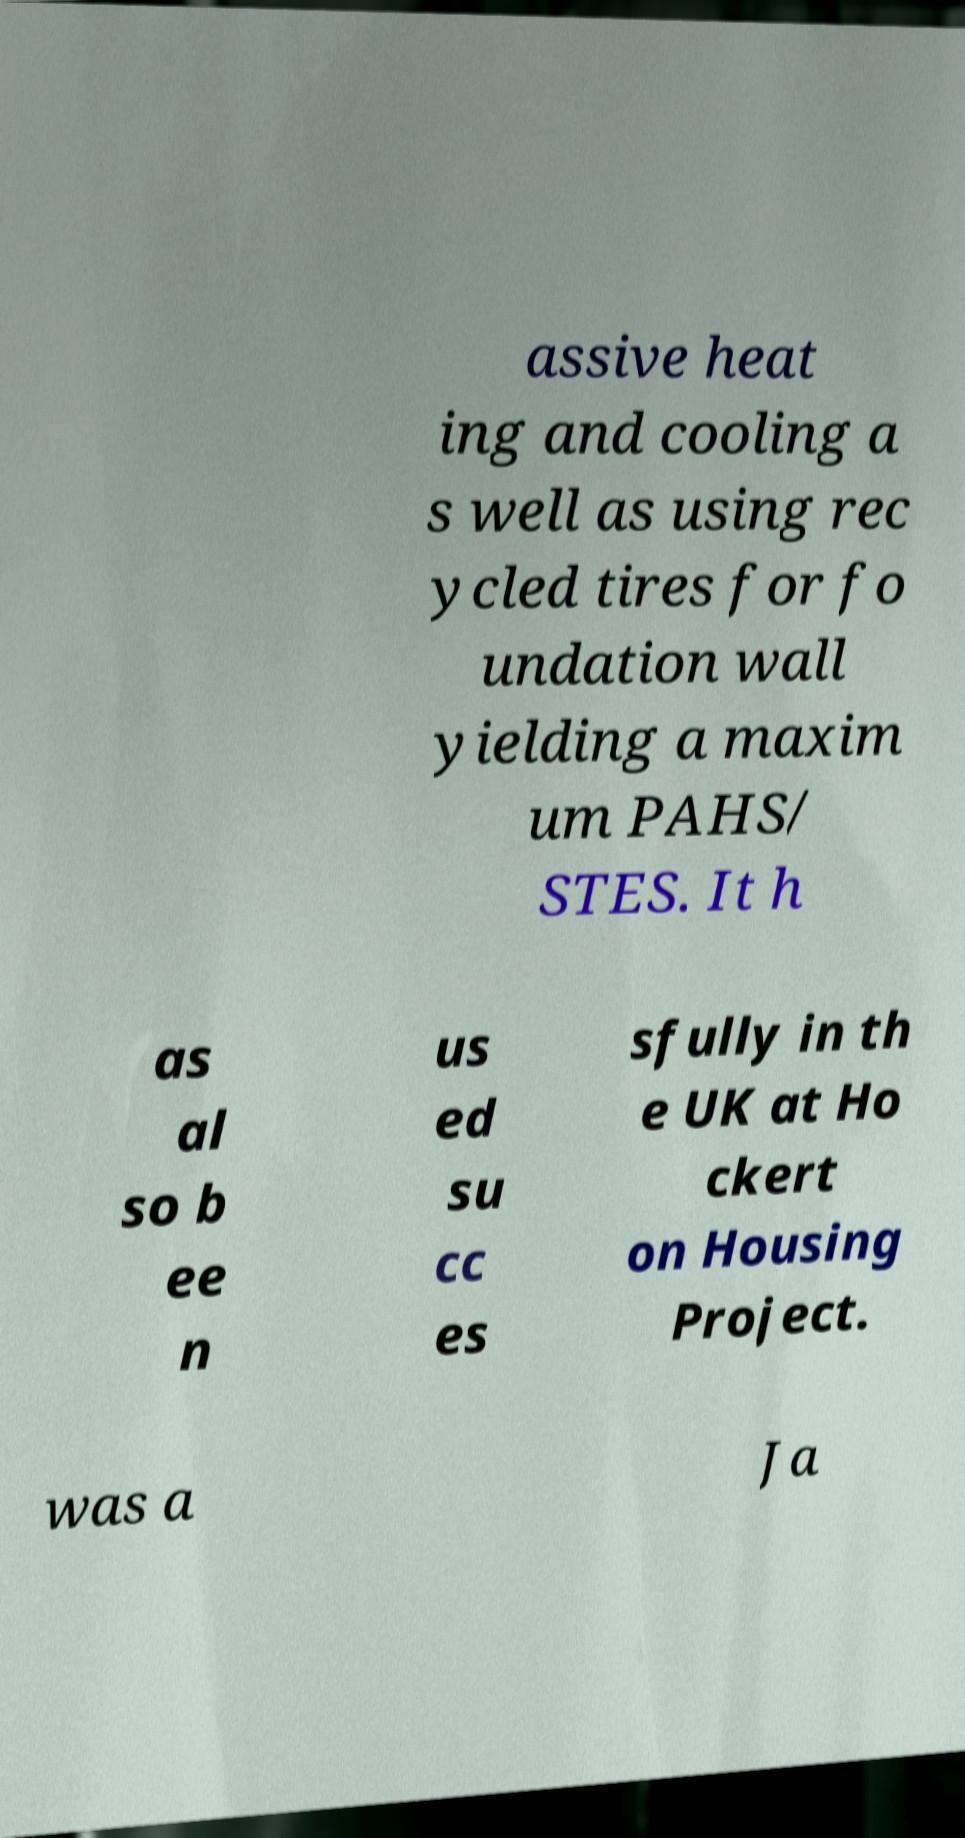What messages or text are displayed in this image? I need them in a readable, typed format. assive heat ing and cooling a s well as using rec ycled tires for fo undation wall yielding a maxim um PAHS/ STES. It h as al so b ee n us ed su cc es sfully in th e UK at Ho ckert on Housing Project. was a Ja 